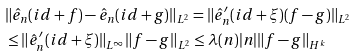Convert formula to latex. <formula><loc_0><loc_0><loc_500><loc_500>& \| \hat { e } _ { n } ( i d + f ) - \hat { e } _ { n } ( i d + g ) \| _ { L ^ { 2 } } = \| \hat { e } _ { n } ^ { \prime } ( i d + \xi ) ( f - g ) \| _ { L ^ { 2 } } \\ & \leq \| \hat { e } _ { n } ^ { \prime } ( i d + \xi ) \| _ { L ^ { \infty } } \| f - g \| _ { L ^ { 2 } } \leq \lambda ( n ) | n | \| f - g \| _ { H ^ { k } }</formula> 